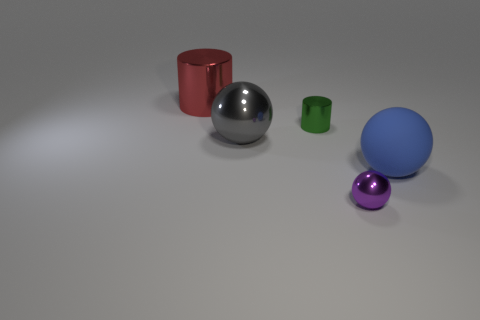Add 2 big metal balls. How many objects exist? 7 Subtract all gray shiny objects. Subtract all big metal things. How many objects are left? 2 Add 1 large matte objects. How many large matte objects are left? 2 Add 2 small purple metallic objects. How many small purple metallic objects exist? 3 Subtract all green cylinders. How many cylinders are left? 1 Subtract all tiny spheres. How many spheres are left? 2 Subtract 1 purple balls. How many objects are left? 4 Subtract all cylinders. How many objects are left? 3 Subtract 2 cylinders. How many cylinders are left? 0 Subtract all red spheres. Subtract all blue cylinders. How many spheres are left? 3 